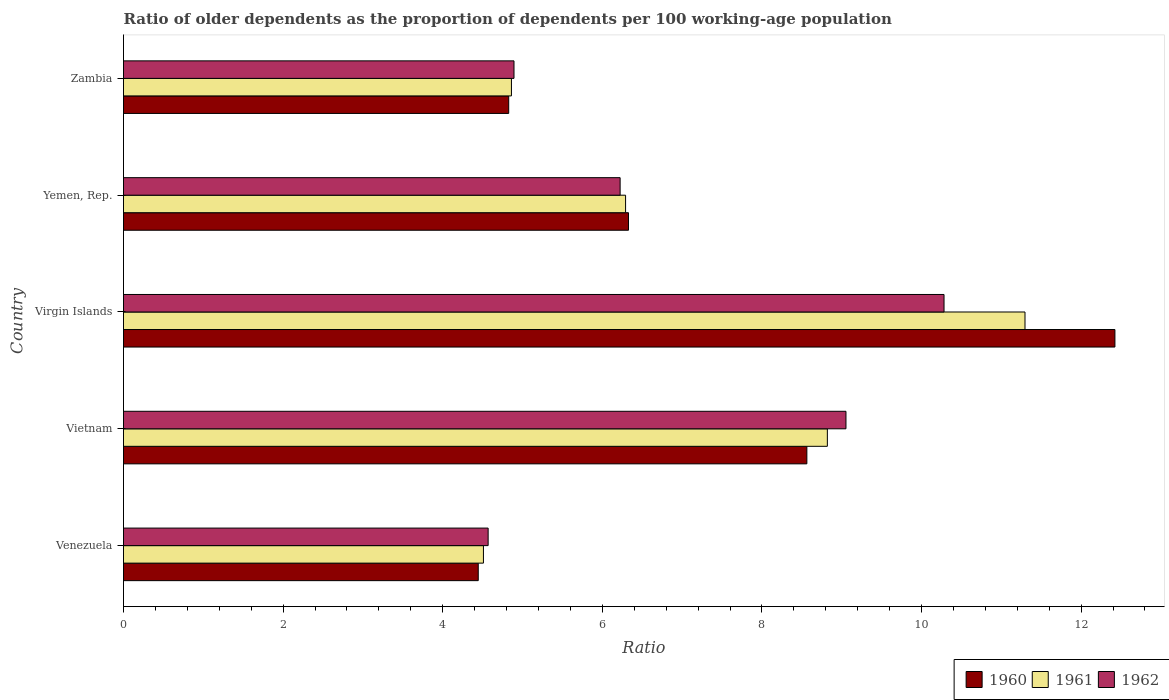How many different coloured bars are there?
Keep it short and to the point. 3. How many groups of bars are there?
Your answer should be compact. 5. Are the number of bars on each tick of the Y-axis equal?
Ensure brevity in your answer.  Yes. What is the label of the 1st group of bars from the top?
Provide a short and direct response. Zambia. In how many cases, is the number of bars for a given country not equal to the number of legend labels?
Ensure brevity in your answer.  0. What is the age dependency ratio(old) in 1962 in Venezuela?
Your answer should be very brief. 4.57. Across all countries, what is the maximum age dependency ratio(old) in 1961?
Your answer should be compact. 11.3. Across all countries, what is the minimum age dependency ratio(old) in 1961?
Your answer should be compact. 4.51. In which country was the age dependency ratio(old) in 1961 maximum?
Keep it short and to the point. Virgin Islands. In which country was the age dependency ratio(old) in 1961 minimum?
Ensure brevity in your answer.  Venezuela. What is the total age dependency ratio(old) in 1962 in the graph?
Ensure brevity in your answer.  35.02. What is the difference between the age dependency ratio(old) in 1960 in Virgin Islands and that in Yemen, Rep.?
Offer a terse response. 6.1. What is the difference between the age dependency ratio(old) in 1960 in Vietnam and the age dependency ratio(old) in 1962 in Venezuela?
Keep it short and to the point. 3.99. What is the average age dependency ratio(old) in 1962 per country?
Provide a short and direct response. 7. What is the difference between the age dependency ratio(old) in 1962 and age dependency ratio(old) in 1961 in Yemen, Rep.?
Offer a very short reply. -0.07. What is the ratio of the age dependency ratio(old) in 1961 in Vietnam to that in Zambia?
Make the answer very short. 1.81. Is the age dependency ratio(old) in 1961 in Vietnam less than that in Virgin Islands?
Provide a succinct answer. Yes. Is the difference between the age dependency ratio(old) in 1962 in Virgin Islands and Yemen, Rep. greater than the difference between the age dependency ratio(old) in 1961 in Virgin Islands and Yemen, Rep.?
Offer a terse response. No. What is the difference between the highest and the second highest age dependency ratio(old) in 1961?
Provide a short and direct response. 2.48. What is the difference between the highest and the lowest age dependency ratio(old) in 1960?
Offer a very short reply. 7.98. What does the 1st bar from the top in Venezuela represents?
Provide a short and direct response. 1962. What does the 2nd bar from the bottom in Virgin Islands represents?
Offer a very short reply. 1961. How many bars are there?
Provide a succinct answer. 15. Are the values on the major ticks of X-axis written in scientific E-notation?
Your response must be concise. No. Does the graph contain any zero values?
Your answer should be compact. No. What is the title of the graph?
Your answer should be compact. Ratio of older dependents as the proportion of dependents per 100 working-age population. Does "1975" appear as one of the legend labels in the graph?
Provide a succinct answer. No. What is the label or title of the X-axis?
Make the answer very short. Ratio. What is the Ratio of 1960 in Venezuela?
Offer a terse response. 4.45. What is the Ratio of 1961 in Venezuela?
Your answer should be very brief. 4.51. What is the Ratio of 1962 in Venezuela?
Keep it short and to the point. 4.57. What is the Ratio of 1960 in Vietnam?
Keep it short and to the point. 8.56. What is the Ratio in 1961 in Vietnam?
Keep it short and to the point. 8.82. What is the Ratio in 1962 in Vietnam?
Your answer should be very brief. 9.05. What is the Ratio of 1960 in Virgin Islands?
Provide a succinct answer. 12.42. What is the Ratio in 1961 in Virgin Islands?
Your response must be concise. 11.3. What is the Ratio in 1962 in Virgin Islands?
Your answer should be very brief. 10.28. What is the Ratio of 1960 in Yemen, Rep.?
Your response must be concise. 6.33. What is the Ratio of 1961 in Yemen, Rep.?
Your answer should be compact. 6.29. What is the Ratio of 1962 in Yemen, Rep.?
Your answer should be very brief. 6.22. What is the Ratio of 1960 in Zambia?
Your answer should be compact. 4.83. What is the Ratio in 1961 in Zambia?
Provide a short and direct response. 4.86. What is the Ratio of 1962 in Zambia?
Offer a terse response. 4.89. Across all countries, what is the maximum Ratio in 1960?
Make the answer very short. 12.42. Across all countries, what is the maximum Ratio of 1961?
Make the answer very short. 11.3. Across all countries, what is the maximum Ratio of 1962?
Make the answer very short. 10.28. Across all countries, what is the minimum Ratio in 1960?
Your answer should be very brief. 4.45. Across all countries, what is the minimum Ratio in 1961?
Provide a short and direct response. 4.51. Across all countries, what is the minimum Ratio of 1962?
Your answer should be compact. 4.57. What is the total Ratio in 1960 in the graph?
Offer a terse response. 36.59. What is the total Ratio in 1961 in the graph?
Offer a very short reply. 35.78. What is the total Ratio in 1962 in the graph?
Your response must be concise. 35.02. What is the difference between the Ratio in 1960 in Venezuela and that in Vietnam?
Offer a terse response. -4.12. What is the difference between the Ratio in 1961 in Venezuela and that in Vietnam?
Provide a short and direct response. -4.31. What is the difference between the Ratio in 1962 in Venezuela and that in Vietnam?
Provide a succinct answer. -4.48. What is the difference between the Ratio in 1960 in Venezuela and that in Virgin Islands?
Offer a terse response. -7.98. What is the difference between the Ratio in 1961 in Venezuela and that in Virgin Islands?
Your answer should be compact. -6.79. What is the difference between the Ratio of 1962 in Venezuela and that in Virgin Islands?
Give a very brief answer. -5.71. What is the difference between the Ratio in 1960 in Venezuela and that in Yemen, Rep.?
Give a very brief answer. -1.88. What is the difference between the Ratio of 1961 in Venezuela and that in Yemen, Rep.?
Keep it short and to the point. -1.78. What is the difference between the Ratio in 1962 in Venezuela and that in Yemen, Rep.?
Offer a very short reply. -1.65. What is the difference between the Ratio in 1960 in Venezuela and that in Zambia?
Give a very brief answer. -0.38. What is the difference between the Ratio in 1961 in Venezuela and that in Zambia?
Ensure brevity in your answer.  -0.35. What is the difference between the Ratio in 1962 in Venezuela and that in Zambia?
Offer a terse response. -0.32. What is the difference between the Ratio in 1960 in Vietnam and that in Virgin Islands?
Keep it short and to the point. -3.86. What is the difference between the Ratio of 1961 in Vietnam and that in Virgin Islands?
Make the answer very short. -2.48. What is the difference between the Ratio in 1962 in Vietnam and that in Virgin Islands?
Offer a terse response. -1.23. What is the difference between the Ratio of 1960 in Vietnam and that in Yemen, Rep.?
Offer a very short reply. 2.24. What is the difference between the Ratio of 1961 in Vietnam and that in Yemen, Rep.?
Your answer should be very brief. 2.53. What is the difference between the Ratio of 1962 in Vietnam and that in Yemen, Rep.?
Offer a very short reply. 2.83. What is the difference between the Ratio of 1960 in Vietnam and that in Zambia?
Your answer should be compact. 3.74. What is the difference between the Ratio of 1961 in Vietnam and that in Zambia?
Your answer should be compact. 3.96. What is the difference between the Ratio in 1962 in Vietnam and that in Zambia?
Your answer should be very brief. 4.16. What is the difference between the Ratio of 1960 in Virgin Islands and that in Yemen, Rep.?
Offer a very short reply. 6.1. What is the difference between the Ratio of 1961 in Virgin Islands and that in Yemen, Rep.?
Offer a terse response. 5.01. What is the difference between the Ratio of 1962 in Virgin Islands and that in Yemen, Rep.?
Your response must be concise. 4.06. What is the difference between the Ratio of 1960 in Virgin Islands and that in Zambia?
Keep it short and to the point. 7.6. What is the difference between the Ratio in 1961 in Virgin Islands and that in Zambia?
Your response must be concise. 6.44. What is the difference between the Ratio in 1962 in Virgin Islands and that in Zambia?
Provide a short and direct response. 5.39. What is the difference between the Ratio in 1960 in Yemen, Rep. and that in Zambia?
Ensure brevity in your answer.  1.5. What is the difference between the Ratio in 1961 in Yemen, Rep. and that in Zambia?
Make the answer very short. 1.43. What is the difference between the Ratio in 1962 in Yemen, Rep. and that in Zambia?
Your answer should be compact. 1.33. What is the difference between the Ratio in 1960 in Venezuela and the Ratio in 1961 in Vietnam?
Give a very brief answer. -4.37. What is the difference between the Ratio of 1960 in Venezuela and the Ratio of 1962 in Vietnam?
Offer a terse response. -4.61. What is the difference between the Ratio in 1961 in Venezuela and the Ratio in 1962 in Vietnam?
Provide a short and direct response. -4.54. What is the difference between the Ratio of 1960 in Venezuela and the Ratio of 1961 in Virgin Islands?
Your answer should be compact. -6.85. What is the difference between the Ratio in 1960 in Venezuela and the Ratio in 1962 in Virgin Islands?
Your response must be concise. -5.84. What is the difference between the Ratio in 1961 in Venezuela and the Ratio in 1962 in Virgin Islands?
Your answer should be compact. -5.77. What is the difference between the Ratio in 1960 in Venezuela and the Ratio in 1961 in Yemen, Rep.?
Your response must be concise. -1.85. What is the difference between the Ratio in 1960 in Venezuela and the Ratio in 1962 in Yemen, Rep.?
Your response must be concise. -1.78. What is the difference between the Ratio of 1961 in Venezuela and the Ratio of 1962 in Yemen, Rep.?
Provide a short and direct response. -1.71. What is the difference between the Ratio of 1960 in Venezuela and the Ratio of 1961 in Zambia?
Keep it short and to the point. -0.42. What is the difference between the Ratio of 1960 in Venezuela and the Ratio of 1962 in Zambia?
Keep it short and to the point. -0.45. What is the difference between the Ratio of 1961 in Venezuela and the Ratio of 1962 in Zambia?
Give a very brief answer. -0.38. What is the difference between the Ratio in 1960 in Vietnam and the Ratio in 1961 in Virgin Islands?
Your answer should be compact. -2.73. What is the difference between the Ratio of 1960 in Vietnam and the Ratio of 1962 in Virgin Islands?
Offer a very short reply. -1.72. What is the difference between the Ratio of 1961 in Vietnam and the Ratio of 1962 in Virgin Islands?
Keep it short and to the point. -1.46. What is the difference between the Ratio of 1960 in Vietnam and the Ratio of 1961 in Yemen, Rep.?
Your answer should be very brief. 2.27. What is the difference between the Ratio of 1960 in Vietnam and the Ratio of 1962 in Yemen, Rep.?
Your answer should be compact. 2.34. What is the difference between the Ratio in 1961 in Vietnam and the Ratio in 1962 in Yemen, Rep.?
Give a very brief answer. 2.6. What is the difference between the Ratio of 1960 in Vietnam and the Ratio of 1961 in Zambia?
Keep it short and to the point. 3.7. What is the difference between the Ratio of 1960 in Vietnam and the Ratio of 1962 in Zambia?
Your response must be concise. 3.67. What is the difference between the Ratio in 1961 in Vietnam and the Ratio in 1962 in Zambia?
Give a very brief answer. 3.93. What is the difference between the Ratio of 1960 in Virgin Islands and the Ratio of 1961 in Yemen, Rep.?
Offer a very short reply. 6.13. What is the difference between the Ratio of 1960 in Virgin Islands and the Ratio of 1962 in Yemen, Rep.?
Offer a very short reply. 6.2. What is the difference between the Ratio of 1961 in Virgin Islands and the Ratio of 1962 in Yemen, Rep.?
Your answer should be compact. 5.07. What is the difference between the Ratio in 1960 in Virgin Islands and the Ratio in 1961 in Zambia?
Offer a very short reply. 7.56. What is the difference between the Ratio of 1960 in Virgin Islands and the Ratio of 1962 in Zambia?
Your answer should be very brief. 7.53. What is the difference between the Ratio in 1961 in Virgin Islands and the Ratio in 1962 in Zambia?
Offer a terse response. 6.4. What is the difference between the Ratio of 1960 in Yemen, Rep. and the Ratio of 1961 in Zambia?
Ensure brevity in your answer.  1.47. What is the difference between the Ratio of 1960 in Yemen, Rep. and the Ratio of 1962 in Zambia?
Provide a succinct answer. 1.43. What is the difference between the Ratio in 1961 in Yemen, Rep. and the Ratio in 1962 in Zambia?
Give a very brief answer. 1.4. What is the average Ratio in 1960 per country?
Offer a terse response. 7.32. What is the average Ratio of 1961 per country?
Offer a very short reply. 7.16. What is the average Ratio of 1962 per country?
Give a very brief answer. 7. What is the difference between the Ratio of 1960 and Ratio of 1961 in Venezuela?
Offer a terse response. -0.07. What is the difference between the Ratio of 1960 and Ratio of 1962 in Venezuela?
Your answer should be very brief. -0.12. What is the difference between the Ratio in 1961 and Ratio in 1962 in Venezuela?
Provide a short and direct response. -0.06. What is the difference between the Ratio in 1960 and Ratio in 1961 in Vietnam?
Make the answer very short. -0.26. What is the difference between the Ratio of 1960 and Ratio of 1962 in Vietnam?
Give a very brief answer. -0.49. What is the difference between the Ratio in 1961 and Ratio in 1962 in Vietnam?
Provide a succinct answer. -0.23. What is the difference between the Ratio in 1960 and Ratio in 1961 in Virgin Islands?
Keep it short and to the point. 1.13. What is the difference between the Ratio of 1960 and Ratio of 1962 in Virgin Islands?
Your answer should be very brief. 2.14. What is the difference between the Ratio in 1961 and Ratio in 1962 in Virgin Islands?
Ensure brevity in your answer.  1.01. What is the difference between the Ratio in 1960 and Ratio in 1961 in Yemen, Rep.?
Ensure brevity in your answer.  0.04. What is the difference between the Ratio of 1960 and Ratio of 1962 in Yemen, Rep.?
Provide a short and direct response. 0.1. What is the difference between the Ratio in 1961 and Ratio in 1962 in Yemen, Rep.?
Offer a terse response. 0.07. What is the difference between the Ratio of 1960 and Ratio of 1961 in Zambia?
Provide a succinct answer. -0.03. What is the difference between the Ratio in 1960 and Ratio in 1962 in Zambia?
Your answer should be very brief. -0.07. What is the difference between the Ratio in 1961 and Ratio in 1962 in Zambia?
Your response must be concise. -0.03. What is the ratio of the Ratio of 1960 in Venezuela to that in Vietnam?
Make the answer very short. 0.52. What is the ratio of the Ratio in 1961 in Venezuela to that in Vietnam?
Ensure brevity in your answer.  0.51. What is the ratio of the Ratio in 1962 in Venezuela to that in Vietnam?
Keep it short and to the point. 0.5. What is the ratio of the Ratio in 1960 in Venezuela to that in Virgin Islands?
Your answer should be compact. 0.36. What is the ratio of the Ratio in 1961 in Venezuela to that in Virgin Islands?
Make the answer very short. 0.4. What is the ratio of the Ratio in 1962 in Venezuela to that in Virgin Islands?
Your answer should be compact. 0.44. What is the ratio of the Ratio in 1960 in Venezuela to that in Yemen, Rep.?
Provide a short and direct response. 0.7. What is the ratio of the Ratio of 1961 in Venezuela to that in Yemen, Rep.?
Provide a succinct answer. 0.72. What is the ratio of the Ratio in 1962 in Venezuela to that in Yemen, Rep.?
Your answer should be compact. 0.73. What is the ratio of the Ratio in 1960 in Venezuela to that in Zambia?
Keep it short and to the point. 0.92. What is the ratio of the Ratio in 1961 in Venezuela to that in Zambia?
Your response must be concise. 0.93. What is the ratio of the Ratio in 1962 in Venezuela to that in Zambia?
Keep it short and to the point. 0.93. What is the ratio of the Ratio of 1960 in Vietnam to that in Virgin Islands?
Offer a terse response. 0.69. What is the ratio of the Ratio in 1961 in Vietnam to that in Virgin Islands?
Your response must be concise. 0.78. What is the ratio of the Ratio in 1962 in Vietnam to that in Virgin Islands?
Provide a short and direct response. 0.88. What is the ratio of the Ratio of 1960 in Vietnam to that in Yemen, Rep.?
Your answer should be very brief. 1.35. What is the ratio of the Ratio in 1961 in Vietnam to that in Yemen, Rep.?
Provide a short and direct response. 1.4. What is the ratio of the Ratio in 1962 in Vietnam to that in Yemen, Rep.?
Ensure brevity in your answer.  1.45. What is the ratio of the Ratio in 1960 in Vietnam to that in Zambia?
Provide a short and direct response. 1.77. What is the ratio of the Ratio in 1961 in Vietnam to that in Zambia?
Ensure brevity in your answer.  1.81. What is the ratio of the Ratio of 1962 in Vietnam to that in Zambia?
Give a very brief answer. 1.85. What is the ratio of the Ratio in 1960 in Virgin Islands to that in Yemen, Rep.?
Give a very brief answer. 1.96. What is the ratio of the Ratio of 1961 in Virgin Islands to that in Yemen, Rep.?
Give a very brief answer. 1.8. What is the ratio of the Ratio in 1962 in Virgin Islands to that in Yemen, Rep.?
Provide a succinct answer. 1.65. What is the ratio of the Ratio in 1960 in Virgin Islands to that in Zambia?
Give a very brief answer. 2.57. What is the ratio of the Ratio in 1961 in Virgin Islands to that in Zambia?
Ensure brevity in your answer.  2.32. What is the ratio of the Ratio in 1962 in Virgin Islands to that in Zambia?
Your answer should be very brief. 2.1. What is the ratio of the Ratio in 1960 in Yemen, Rep. to that in Zambia?
Make the answer very short. 1.31. What is the ratio of the Ratio of 1961 in Yemen, Rep. to that in Zambia?
Provide a short and direct response. 1.29. What is the ratio of the Ratio of 1962 in Yemen, Rep. to that in Zambia?
Make the answer very short. 1.27. What is the difference between the highest and the second highest Ratio in 1960?
Make the answer very short. 3.86. What is the difference between the highest and the second highest Ratio in 1961?
Your answer should be very brief. 2.48. What is the difference between the highest and the second highest Ratio in 1962?
Offer a very short reply. 1.23. What is the difference between the highest and the lowest Ratio of 1960?
Ensure brevity in your answer.  7.98. What is the difference between the highest and the lowest Ratio in 1961?
Offer a terse response. 6.79. What is the difference between the highest and the lowest Ratio of 1962?
Give a very brief answer. 5.71. 